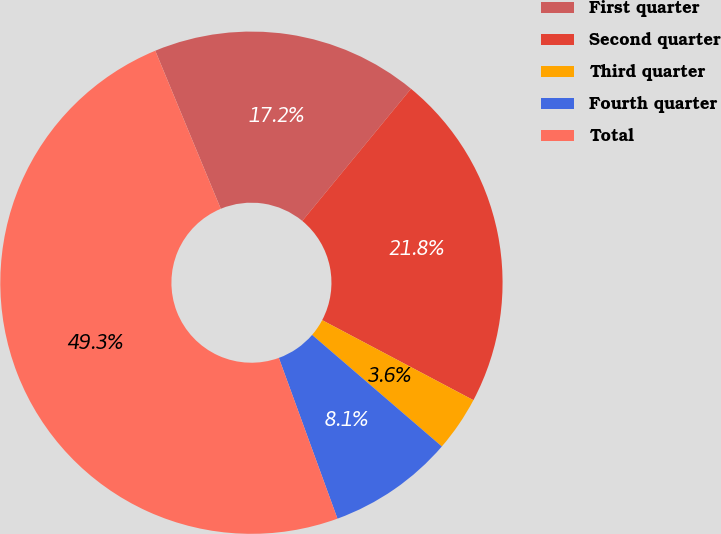Convert chart. <chart><loc_0><loc_0><loc_500><loc_500><pie_chart><fcel>First quarter<fcel>Second quarter<fcel>Third quarter<fcel>Fourth quarter<fcel>Total<nl><fcel>17.21%<fcel>21.79%<fcel>3.56%<fcel>8.13%<fcel>49.31%<nl></chart> 